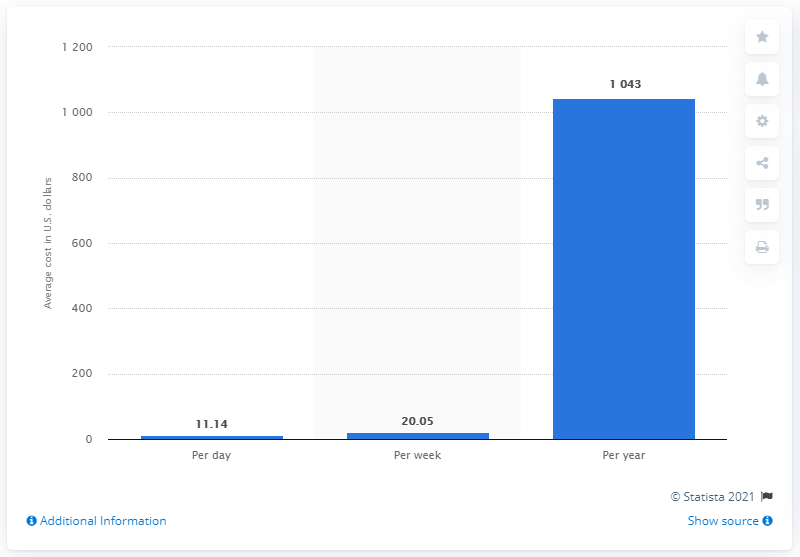List a handful of essential elements in this visual. In 2015, the average cost of eating out for lunch in the United States was $11.14. 